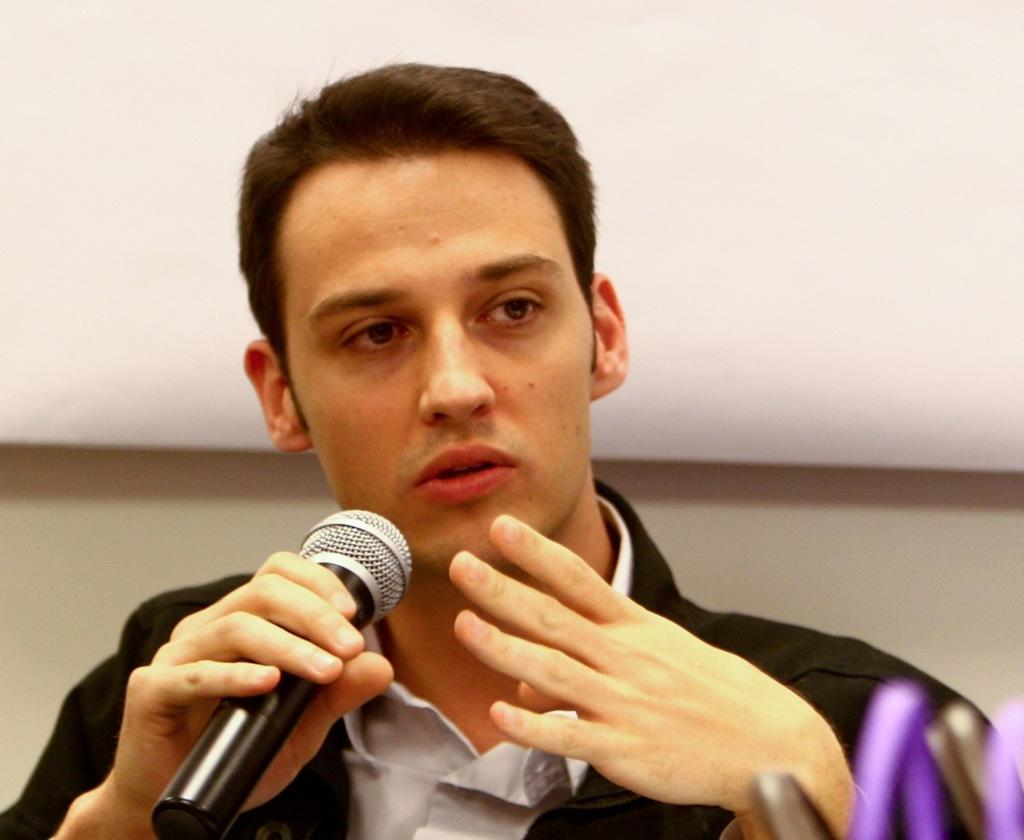Who is the main subject in the image? There is a man in the image. What is the man wearing? The man is wearing a black suit. What is the man holding in front of his face? The man is holding a microphone in front of his face. What color is the background of the image? The background of the image is white. What type of pain is the man experiencing in the image? There is there any indication of pain or discomfort in the image? 